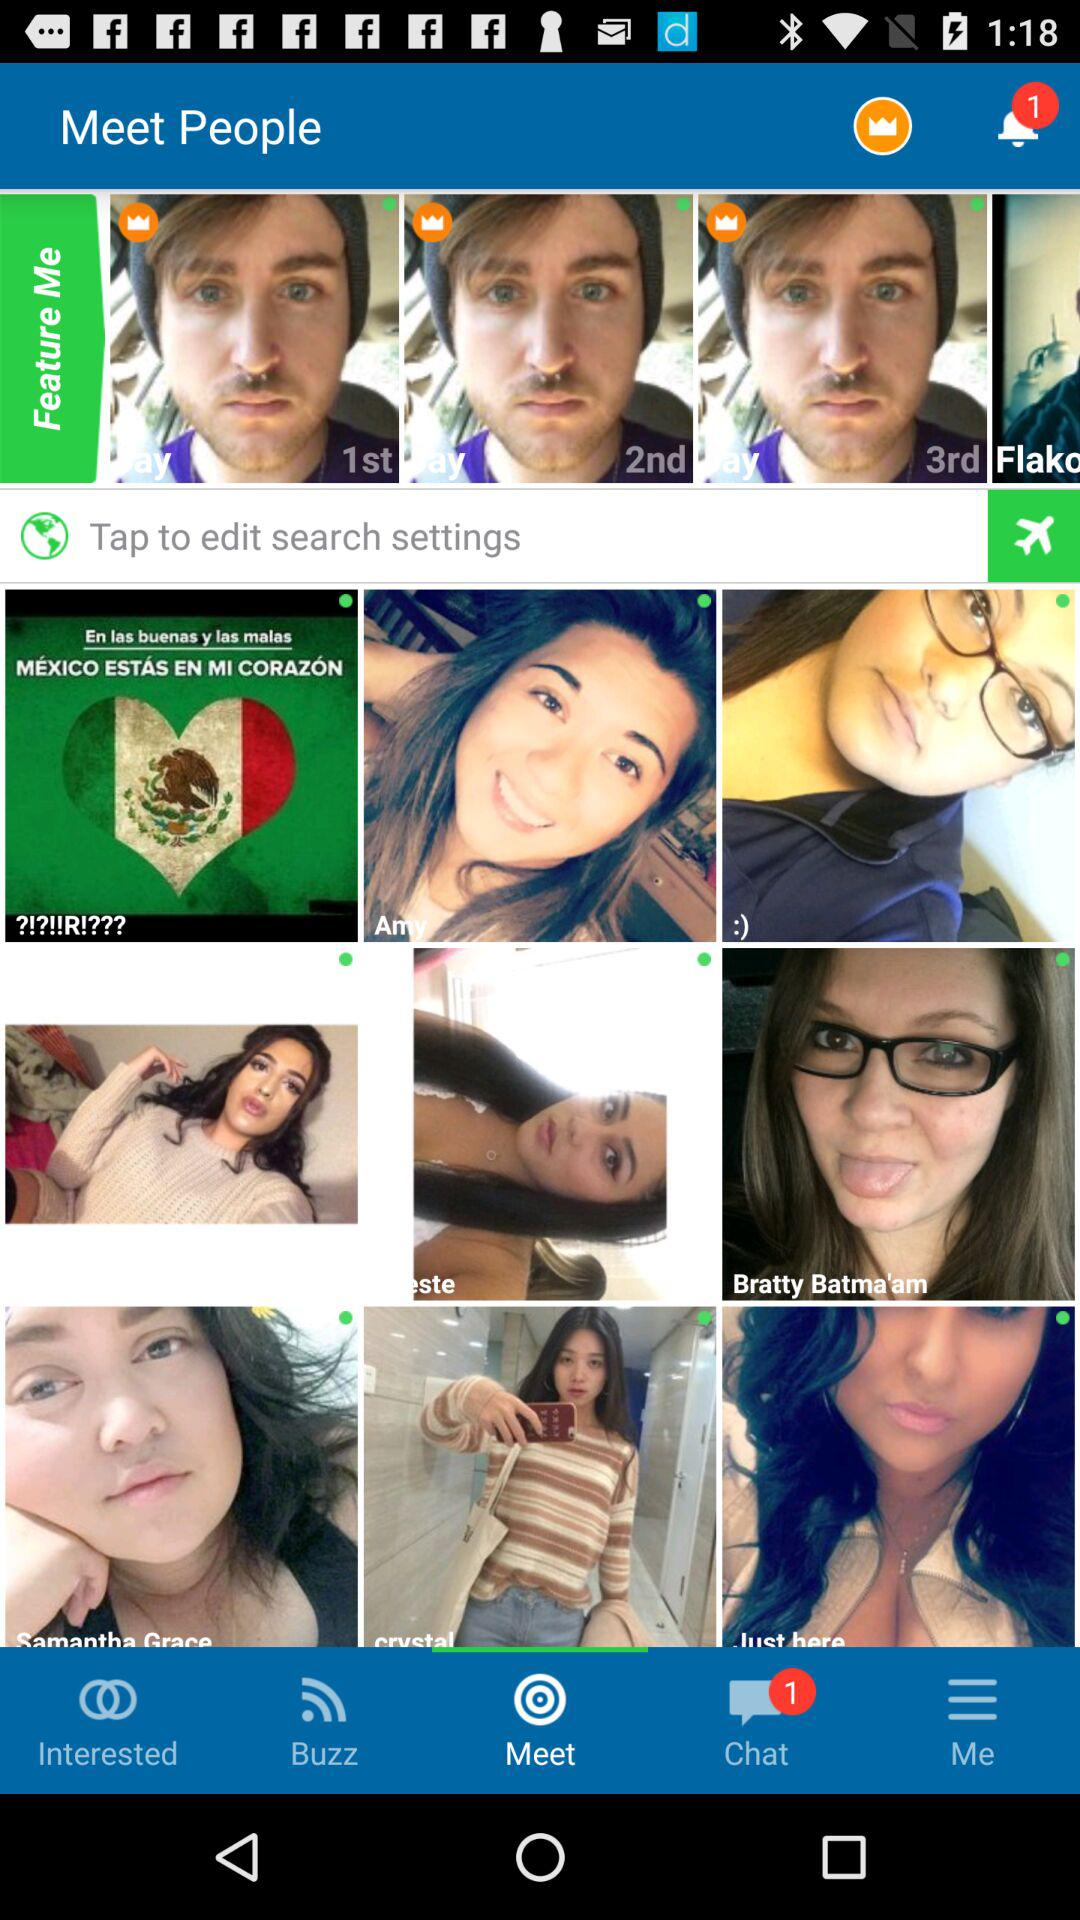How many notifications are received? There is 1 notification received. 